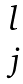<formula> <loc_0><loc_0><loc_500><loc_500>\begin{matrix} l \\ j \end{matrix}</formula> 